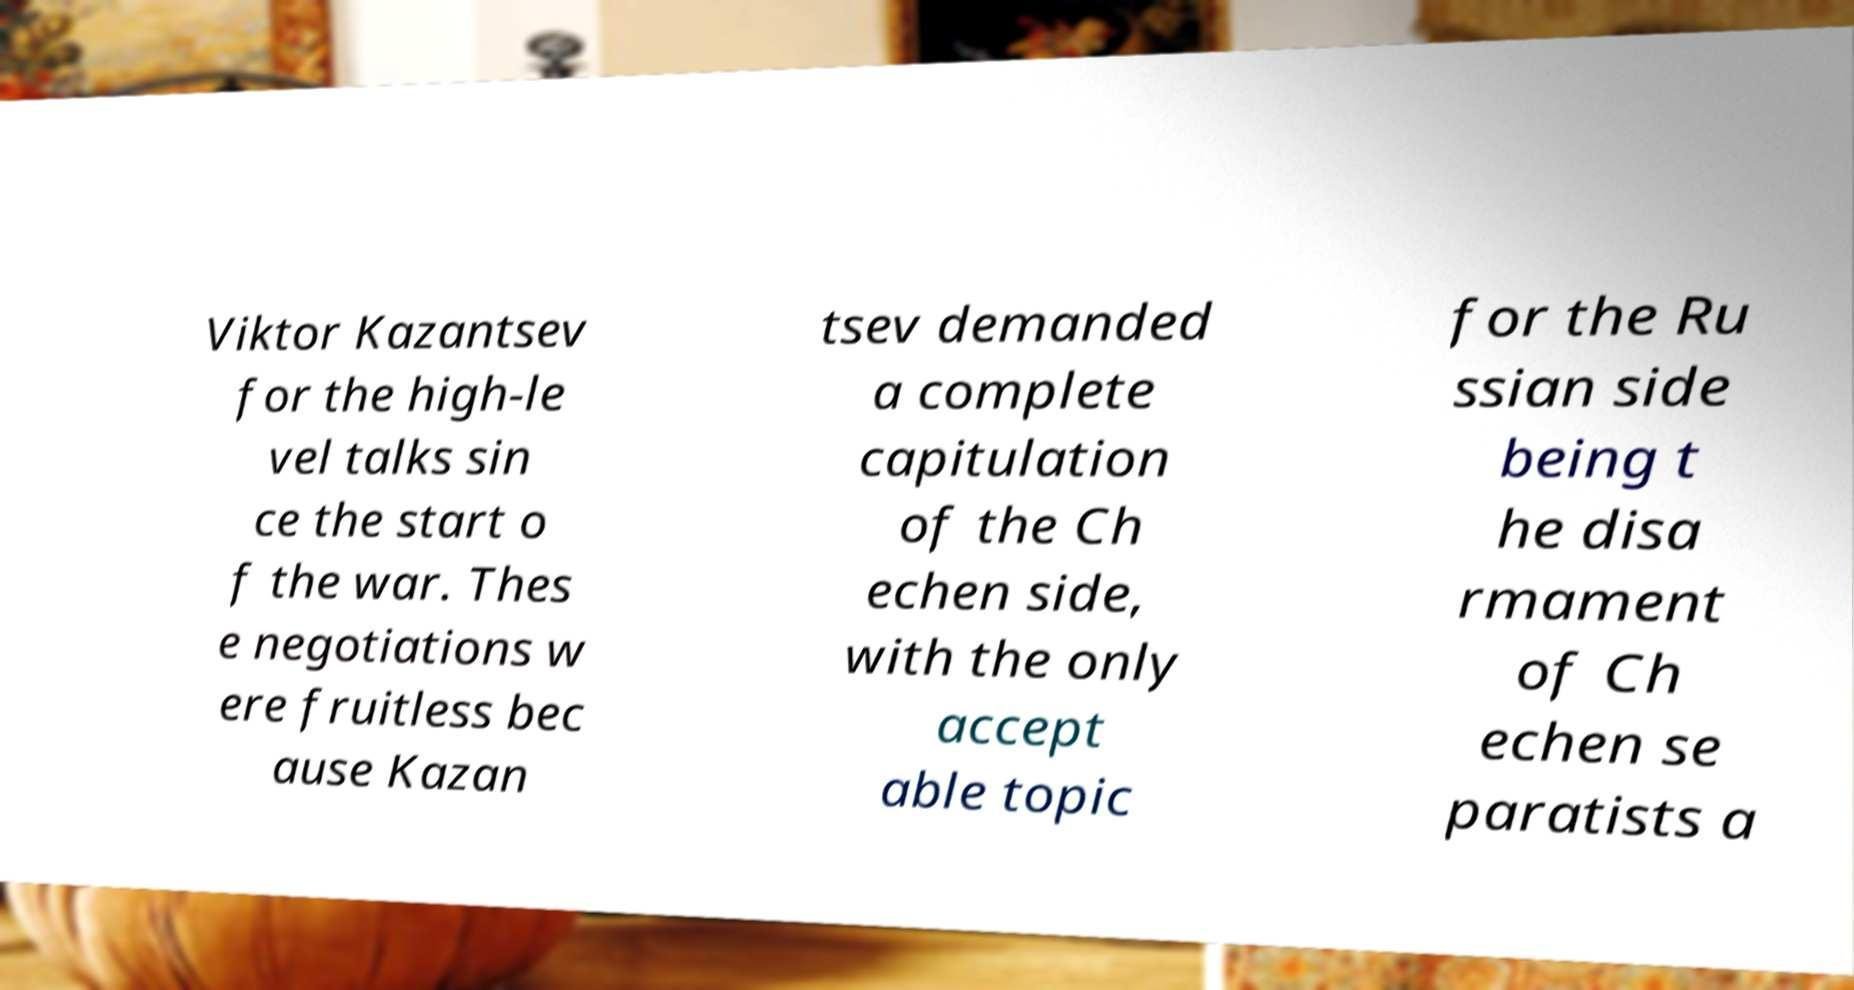Could you extract and type out the text from this image? Viktor Kazantsev for the high-le vel talks sin ce the start o f the war. Thes e negotiations w ere fruitless bec ause Kazan tsev demanded a complete capitulation of the Ch echen side, with the only accept able topic for the Ru ssian side being t he disa rmament of Ch echen se paratists a 